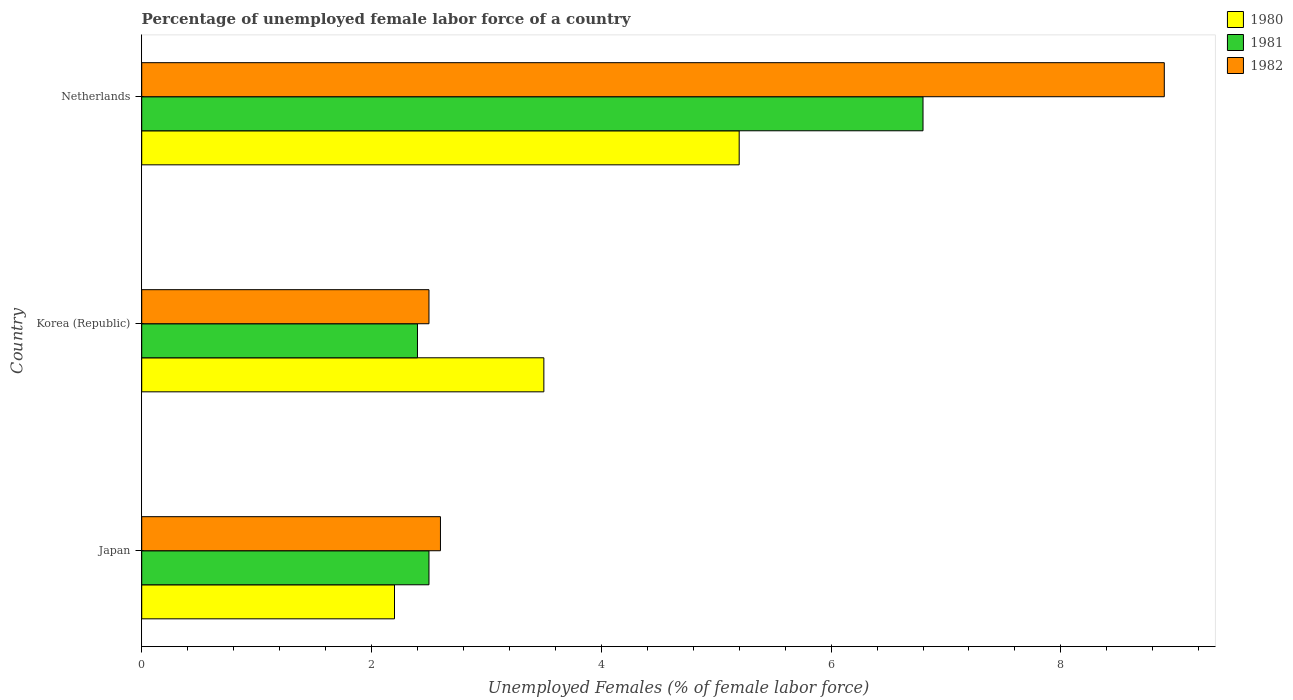Are the number of bars on each tick of the Y-axis equal?
Ensure brevity in your answer.  Yes. How many bars are there on the 3rd tick from the top?
Provide a short and direct response. 3. In how many cases, is the number of bars for a given country not equal to the number of legend labels?
Ensure brevity in your answer.  0. Across all countries, what is the maximum percentage of unemployed female labor force in 1981?
Make the answer very short. 6.8. Across all countries, what is the minimum percentage of unemployed female labor force in 1982?
Your answer should be compact. 2.5. In which country was the percentage of unemployed female labor force in 1980 maximum?
Make the answer very short. Netherlands. In which country was the percentage of unemployed female labor force in 1981 minimum?
Your answer should be compact. Korea (Republic). What is the total percentage of unemployed female labor force in 1981 in the graph?
Make the answer very short. 11.7. What is the difference between the percentage of unemployed female labor force in 1981 in Japan and that in Korea (Republic)?
Your answer should be compact. 0.1. What is the difference between the percentage of unemployed female labor force in 1980 in Japan and the percentage of unemployed female labor force in 1981 in Korea (Republic)?
Offer a very short reply. -0.2. What is the average percentage of unemployed female labor force in 1980 per country?
Make the answer very short. 3.63. What is the difference between the percentage of unemployed female labor force in 1982 and percentage of unemployed female labor force in 1981 in Netherlands?
Provide a succinct answer. 2.1. What is the ratio of the percentage of unemployed female labor force in 1981 in Korea (Republic) to that in Netherlands?
Offer a terse response. 0.35. Is the percentage of unemployed female labor force in 1981 in Korea (Republic) less than that in Netherlands?
Your answer should be very brief. Yes. Is the difference between the percentage of unemployed female labor force in 1982 in Japan and Korea (Republic) greater than the difference between the percentage of unemployed female labor force in 1981 in Japan and Korea (Republic)?
Your answer should be very brief. No. What is the difference between the highest and the second highest percentage of unemployed female labor force in 1981?
Give a very brief answer. 4.3. What is the difference between the highest and the lowest percentage of unemployed female labor force in 1980?
Give a very brief answer. 3. Is the sum of the percentage of unemployed female labor force in 1980 in Japan and Netherlands greater than the maximum percentage of unemployed female labor force in 1981 across all countries?
Give a very brief answer. Yes. What does the 2nd bar from the top in Korea (Republic) represents?
Offer a terse response. 1981. Is it the case that in every country, the sum of the percentage of unemployed female labor force in 1982 and percentage of unemployed female labor force in 1981 is greater than the percentage of unemployed female labor force in 1980?
Provide a short and direct response. Yes. Are all the bars in the graph horizontal?
Your answer should be very brief. Yes. How many countries are there in the graph?
Give a very brief answer. 3. Are the values on the major ticks of X-axis written in scientific E-notation?
Your answer should be very brief. No. Does the graph contain grids?
Offer a terse response. No. How many legend labels are there?
Your answer should be compact. 3. How are the legend labels stacked?
Your answer should be very brief. Vertical. What is the title of the graph?
Your response must be concise. Percentage of unemployed female labor force of a country. What is the label or title of the X-axis?
Ensure brevity in your answer.  Unemployed Females (% of female labor force). What is the label or title of the Y-axis?
Provide a succinct answer. Country. What is the Unemployed Females (% of female labor force) in 1980 in Japan?
Provide a short and direct response. 2.2. What is the Unemployed Females (% of female labor force) in 1981 in Japan?
Ensure brevity in your answer.  2.5. What is the Unemployed Females (% of female labor force) in 1982 in Japan?
Make the answer very short. 2.6. What is the Unemployed Females (% of female labor force) in 1980 in Korea (Republic)?
Ensure brevity in your answer.  3.5. What is the Unemployed Females (% of female labor force) of 1981 in Korea (Republic)?
Your answer should be very brief. 2.4. What is the Unemployed Females (% of female labor force) of 1982 in Korea (Republic)?
Provide a short and direct response. 2.5. What is the Unemployed Females (% of female labor force) in 1980 in Netherlands?
Offer a very short reply. 5.2. What is the Unemployed Females (% of female labor force) of 1981 in Netherlands?
Ensure brevity in your answer.  6.8. What is the Unemployed Females (% of female labor force) of 1982 in Netherlands?
Your answer should be very brief. 8.9. Across all countries, what is the maximum Unemployed Females (% of female labor force) of 1980?
Offer a terse response. 5.2. Across all countries, what is the maximum Unemployed Females (% of female labor force) of 1981?
Provide a short and direct response. 6.8. Across all countries, what is the maximum Unemployed Females (% of female labor force) in 1982?
Your answer should be very brief. 8.9. Across all countries, what is the minimum Unemployed Females (% of female labor force) in 1980?
Give a very brief answer. 2.2. Across all countries, what is the minimum Unemployed Females (% of female labor force) in 1981?
Your answer should be very brief. 2.4. Across all countries, what is the minimum Unemployed Females (% of female labor force) in 1982?
Provide a short and direct response. 2.5. What is the difference between the Unemployed Females (% of female labor force) in 1980 in Japan and that in Netherlands?
Make the answer very short. -3. What is the difference between the Unemployed Females (% of female labor force) in 1981 in Japan and that in Netherlands?
Offer a terse response. -4.3. What is the difference between the Unemployed Females (% of female labor force) of 1982 in Korea (Republic) and that in Netherlands?
Offer a very short reply. -6.4. What is the difference between the Unemployed Females (% of female labor force) of 1980 in Japan and the Unemployed Females (% of female labor force) of 1981 in Korea (Republic)?
Keep it short and to the point. -0.2. What is the difference between the Unemployed Females (% of female labor force) in 1981 in Japan and the Unemployed Females (% of female labor force) in 1982 in Korea (Republic)?
Give a very brief answer. 0. What is the difference between the Unemployed Females (% of female labor force) of 1981 in Japan and the Unemployed Females (% of female labor force) of 1982 in Netherlands?
Offer a terse response. -6.4. What is the average Unemployed Females (% of female labor force) in 1980 per country?
Provide a short and direct response. 3.63. What is the average Unemployed Females (% of female labor force) of 1982 per country?
Ensure brevity in your answer.  4.67. What is the difference between the Unemployed Females (% of female labor force) in 1980 and Unemployed Females (% of female labor force) in 1982 in Japan?
Your answer should be compact. -0.4. What is the difference between the Unemployed Females (% of female labor force) of 1981 and Unemployed Females (% of female labor force) of 1982 in Japan?
Give a very brief answer. -0.1. What is the difference between the Unemployed Females (% of female labor force) of 1980 and Unemployed Females (% of female labor force) of 1982 in Korea (Republic)?
Give a very brief answer. 1. What is the difference between the Unemployed Females (% of female labor force) of 1980 and Unemployed Females (% of female labor force) of 1982 in Netherlands?
Ensure brevity in your answer.  -3.7. What is the difference between the Unemployed Females (% of female labor force) in 1981 and Unemployed Females (% of female labor force) in 1982 in Netherlands?
Your answer should be very brief. -2.1. What is the ratio of the Unemployed Females (% of female labor force) in 1980 in Japan to that in Korea (Republic)?
Offer a very short reply. 0.63. What is the ratio of the Unemployed Females (% of female labor force) in 1981 in Japan to that in Korea (Republic)?
Provide a succinct answer. 1.04. What is the ratio of the Unemployed Females (% of female labor force) of 1982 in Japan to that in Korea (Republic)?
Provide a succinct answer. 1.04. What is the ratio of the Unemployed Females (% of female labor force) of 1980 in Japan to that in Netherlands?
Offer a terse response. 0.42. What is the ratio of the Unemployed Females (% of female labor force) in 1981 in Japan to that in Netherlands?
Provide a short and direct response. 0.37. What is the ratio of the Unemployed Females (% of female labor force) in 1982 in Japan to that in Netherlands?
Ensure brevity in your answer.  0.29. What is the ratio of the Unemployed Females (% of female labor force) in 1980 in Korea (Republic) to that in Netherlands?
Your answer should be compact. 0.67. What is the ratio of the Unemployed Females (% of female labor force) in 1981 in Korea (Republic) to that in Netherlands?
Offer a terse response. 0.35. What is the ratio of the Unemployed Females (% of female labor force) in 1982 in Korea (Republic) to that in Netherlands?
Your response must be concise. 0.28. What is the difference between the highest and the second highest Unemployed Females (% of female labor force) in 1981?
Provide a short and direct response. 4.3. What is the difference between the highest and the lowest Unemployed Females (% of female labor force) in 1980?
Keep it short and to the point. 3. What is the difference between the highest and the lowest Unemployed Females (% of female labor force) in 1981?
Offer a very short reply. 4.4. 